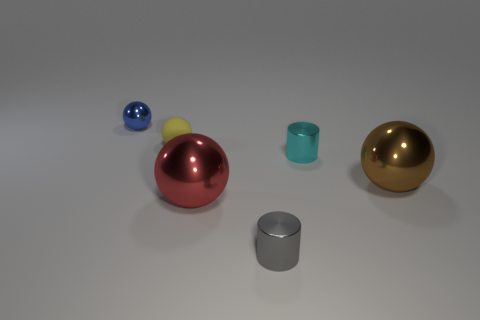There is a gray object that is the same size as the yellow rubber thing; what is its shape?
Your response must be concise. Cylinder. What is the shape of the tiny gray shiny thing?
Ensure brevity in your answer.  Cylinder. Does the large sphere that is right of the small cyan metal cylinder have the same material as the gray thing?
Offer a very short reply. Yes. There is a metallic ball that is behind the big brown object that is in front of the tiny yellow sphere; what size is it?
Give a very brief answer. Small. The small shiny object that is both to the right of the large red metallic object and behind the red metal ball is what color?
Your answer should be very brief. Cyan. What material is the cyan cylinder that is the same size as the gray metallic object?
Ensure brevity in your answer.  Metal. How many other things are made of the same material as the yellow sphere?
Offer a very short reply. 0. There is a thing in front of the red metal sphere; is it the same color as the big sphere left of the large brown thing?
Offer a terse response. No. The large metallic object that is on the right side of the tiny shiny cylinder that is in front of the large red sphere is what shape?
Make the answer very short. Sphere. What number of other things are the same color as the small shiny sphere?
Your answer should be compact. 0. 